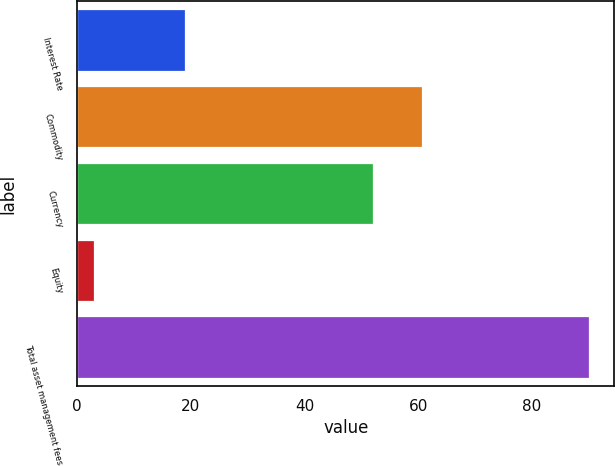Convert chart. <chart><loc_0><loc_0><loc_500><loc_500><bar_chart><fcel>Interest Rate<fcel>Commodity<fcel>Currency<fcel>Equity<fcel>Total asset management fees<nl><fcel>19<fcel>60.7<fcel>52<fcel>3<fcel>90<nl></chart> 